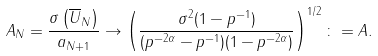<formula> <loc_0><loc_0><loc_500><loc_500>A _ { N } = \frac { \sigma \left ( \overline { U } _ { N } \right ) } { a _ { N + 1 } } \to \left ( \frac { \sigma ^ { 2 } ( 1 - p ^ { - 1 } ) } { ( p ^ { - 2 \alpha } - p ^ { - 1 } ) ( 1 - p ^ { - 2 \alpha } ) } \right ) ^ { 1 / 2 } \colon = A .</formula> 